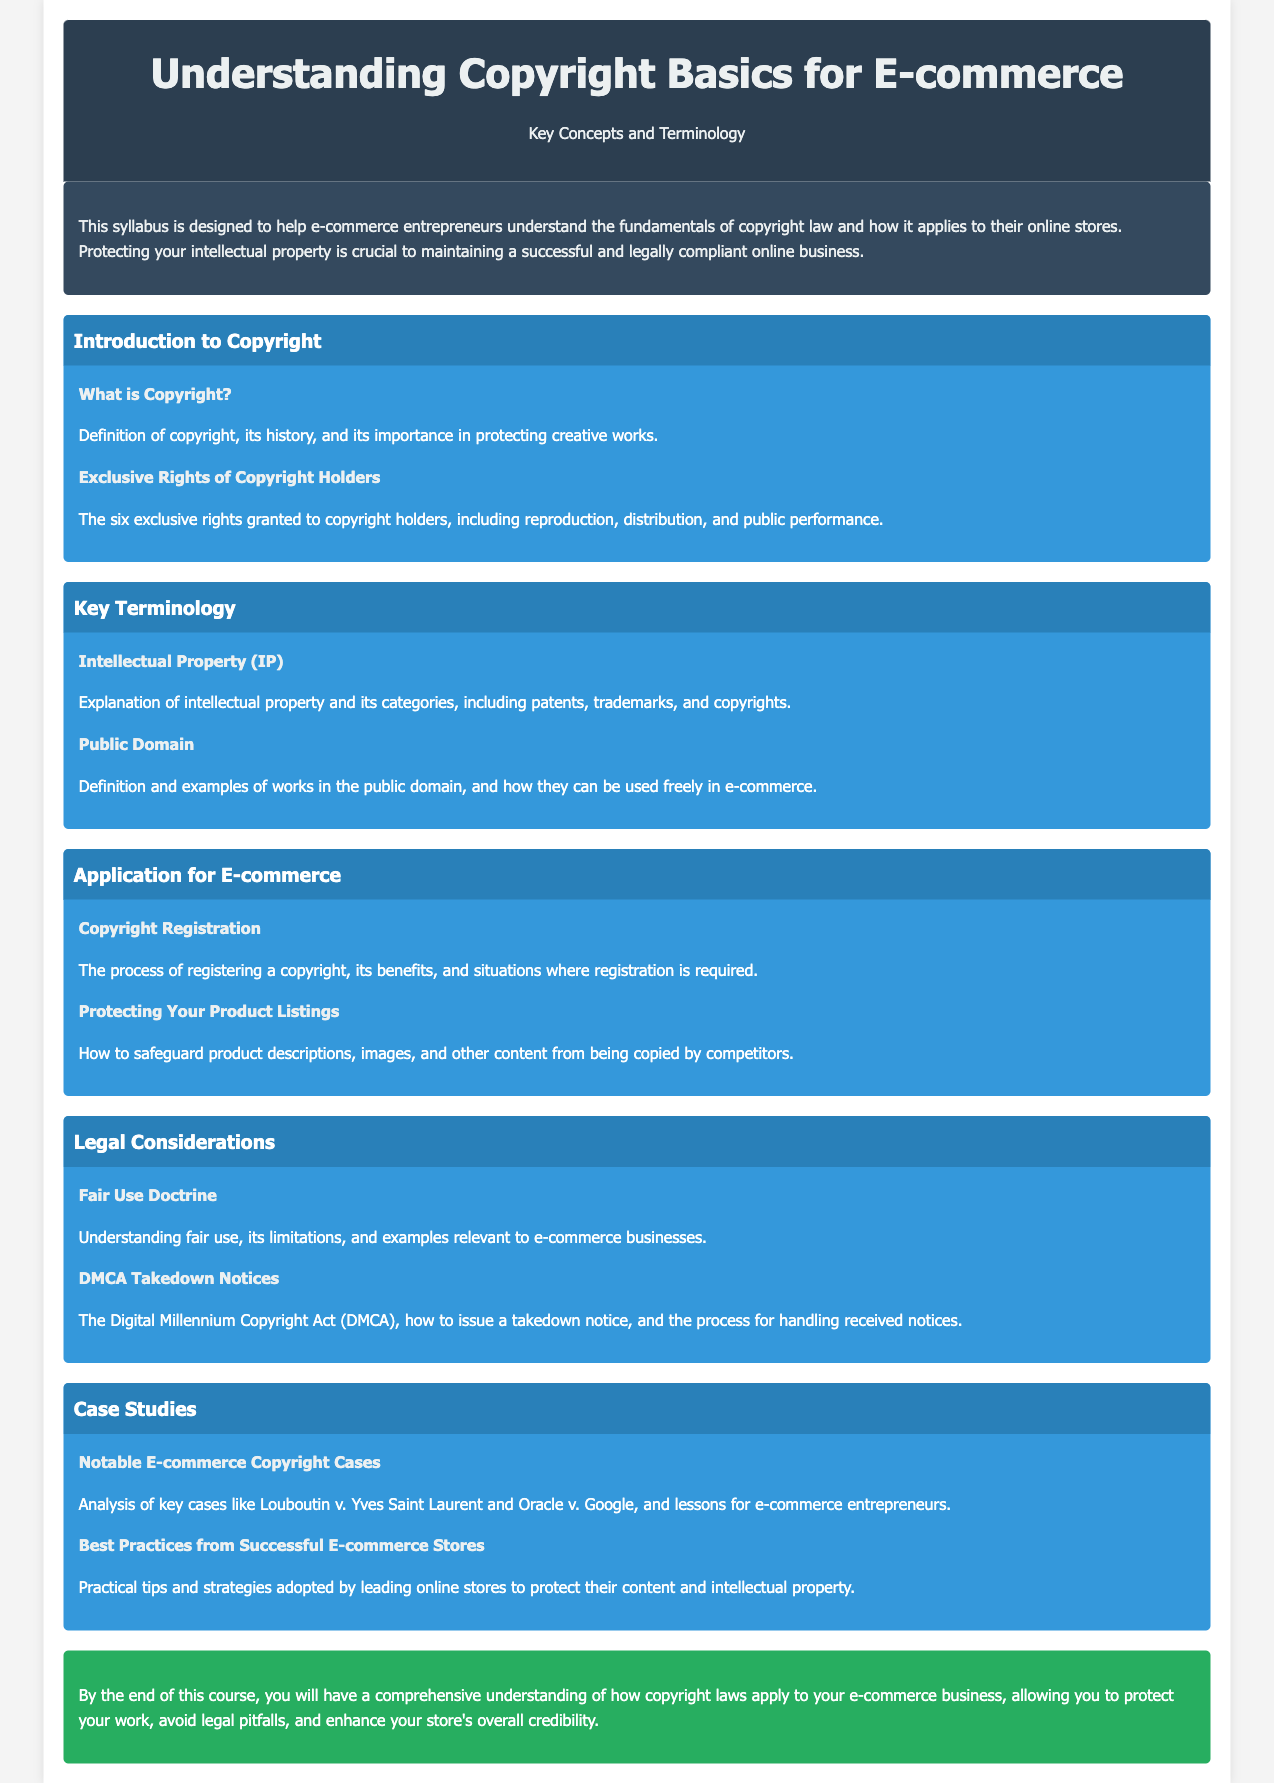What is the title of the syllabus? The title of the syllabus is prominently displayed in the header section of the document.
Answer: Understanding Copyright Basics for E-commerce How many exclusive rights are granted to copyright holders? This information is mentioned in the section about exclusive rights of copyright holders.
Answer: Six What does IP stand for in the context of this syllabus? The abbreviation IP is mentioned in the key terminology section as referring to a specific type of property.
Answer: Intellectual Property What is the topic of the last module? The last module's title can be found in the modules section, indicating its content focus.
Answer: Case Studies What is one benefit of copyright registration? This is referred to in the copyright registration topic that discusses its advantages.
Answer: Benefits What is the fair use doctrine? This term is defined in the legal considerations module and relates to copyright law's practical application.
Answer: Understanding fair use What is the conclusion's purpose in the document? The conclusion summarizes the content and objectives of the course found in the final section.
Answer: Comprehensive understanding What is the color scheme used for the introduction section? This detail can be observed directly from the code and visual design of the intro section.
Answer: Dark blue background with white text 